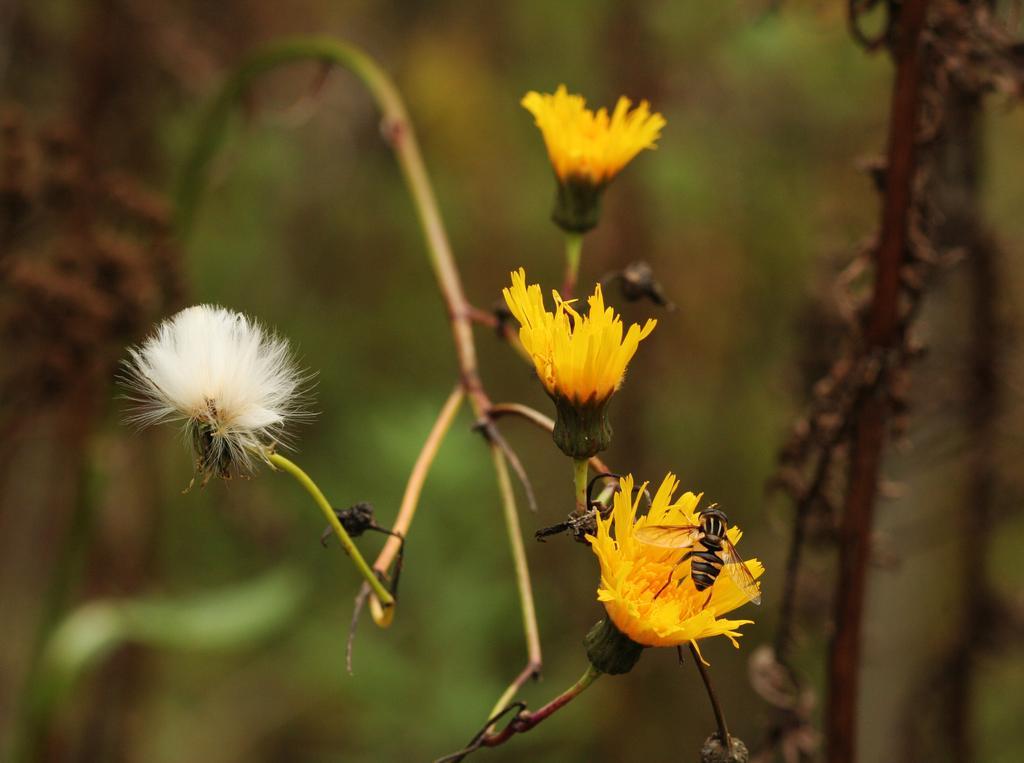Could you give a brief overview of what you see in this image? In the picture there are some flowers to the branch of a plant and there is an insect on one of the flower. 